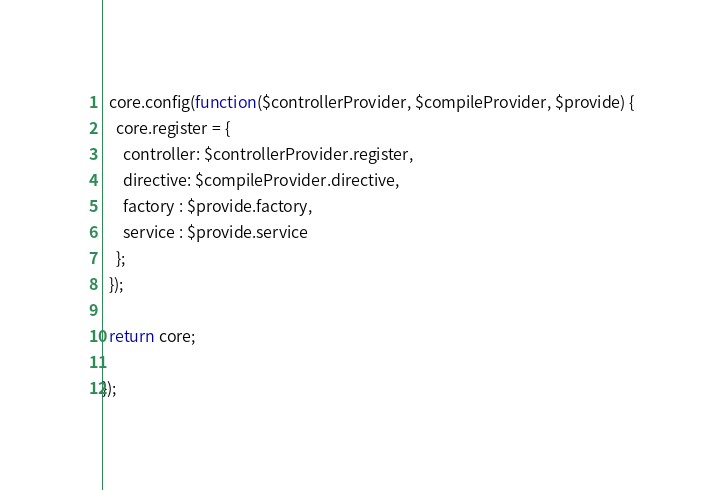<code> <loc_0><loc_0><loc_500><loc_500><_JavaScript_>
  core.config(function($controllerProvider, $compileProvider, $provide) {
    core.register = {
      controller: $controllerProvider.register,
      directive: $compileProvider.directive,
      factory : $provide.factory,
      service : $provide.service
    };
  });

  return core;

});
</code> 